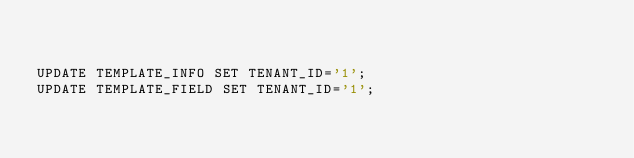<code> <loc_0><loc_0><loc_500><loc_500><_SQL_>

UPDATE TEMPLATE_INFO SET TENANT_ID='1';
UPDATE TEMPLATE_FIELD SET TENANT_ID='1';

</code> 